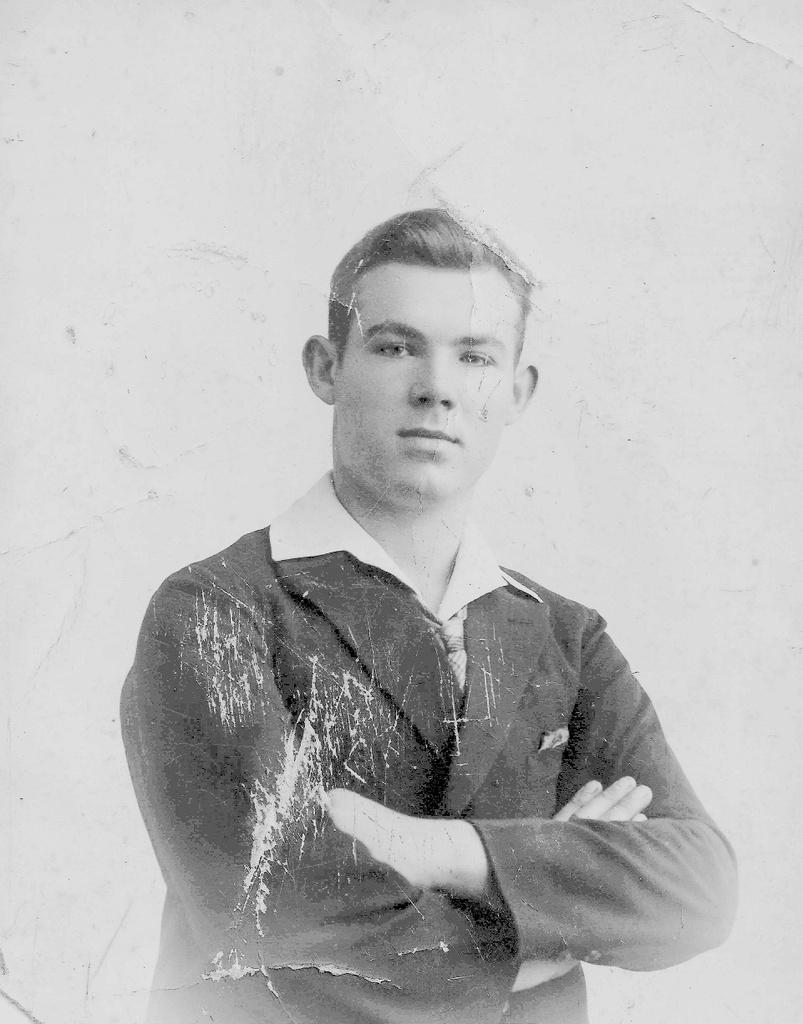What is the main subject of the image? There is a photograph of a person in the image. How many pets are visible in the image? There are no pets visible in the image; it only features a photograph of a person. 